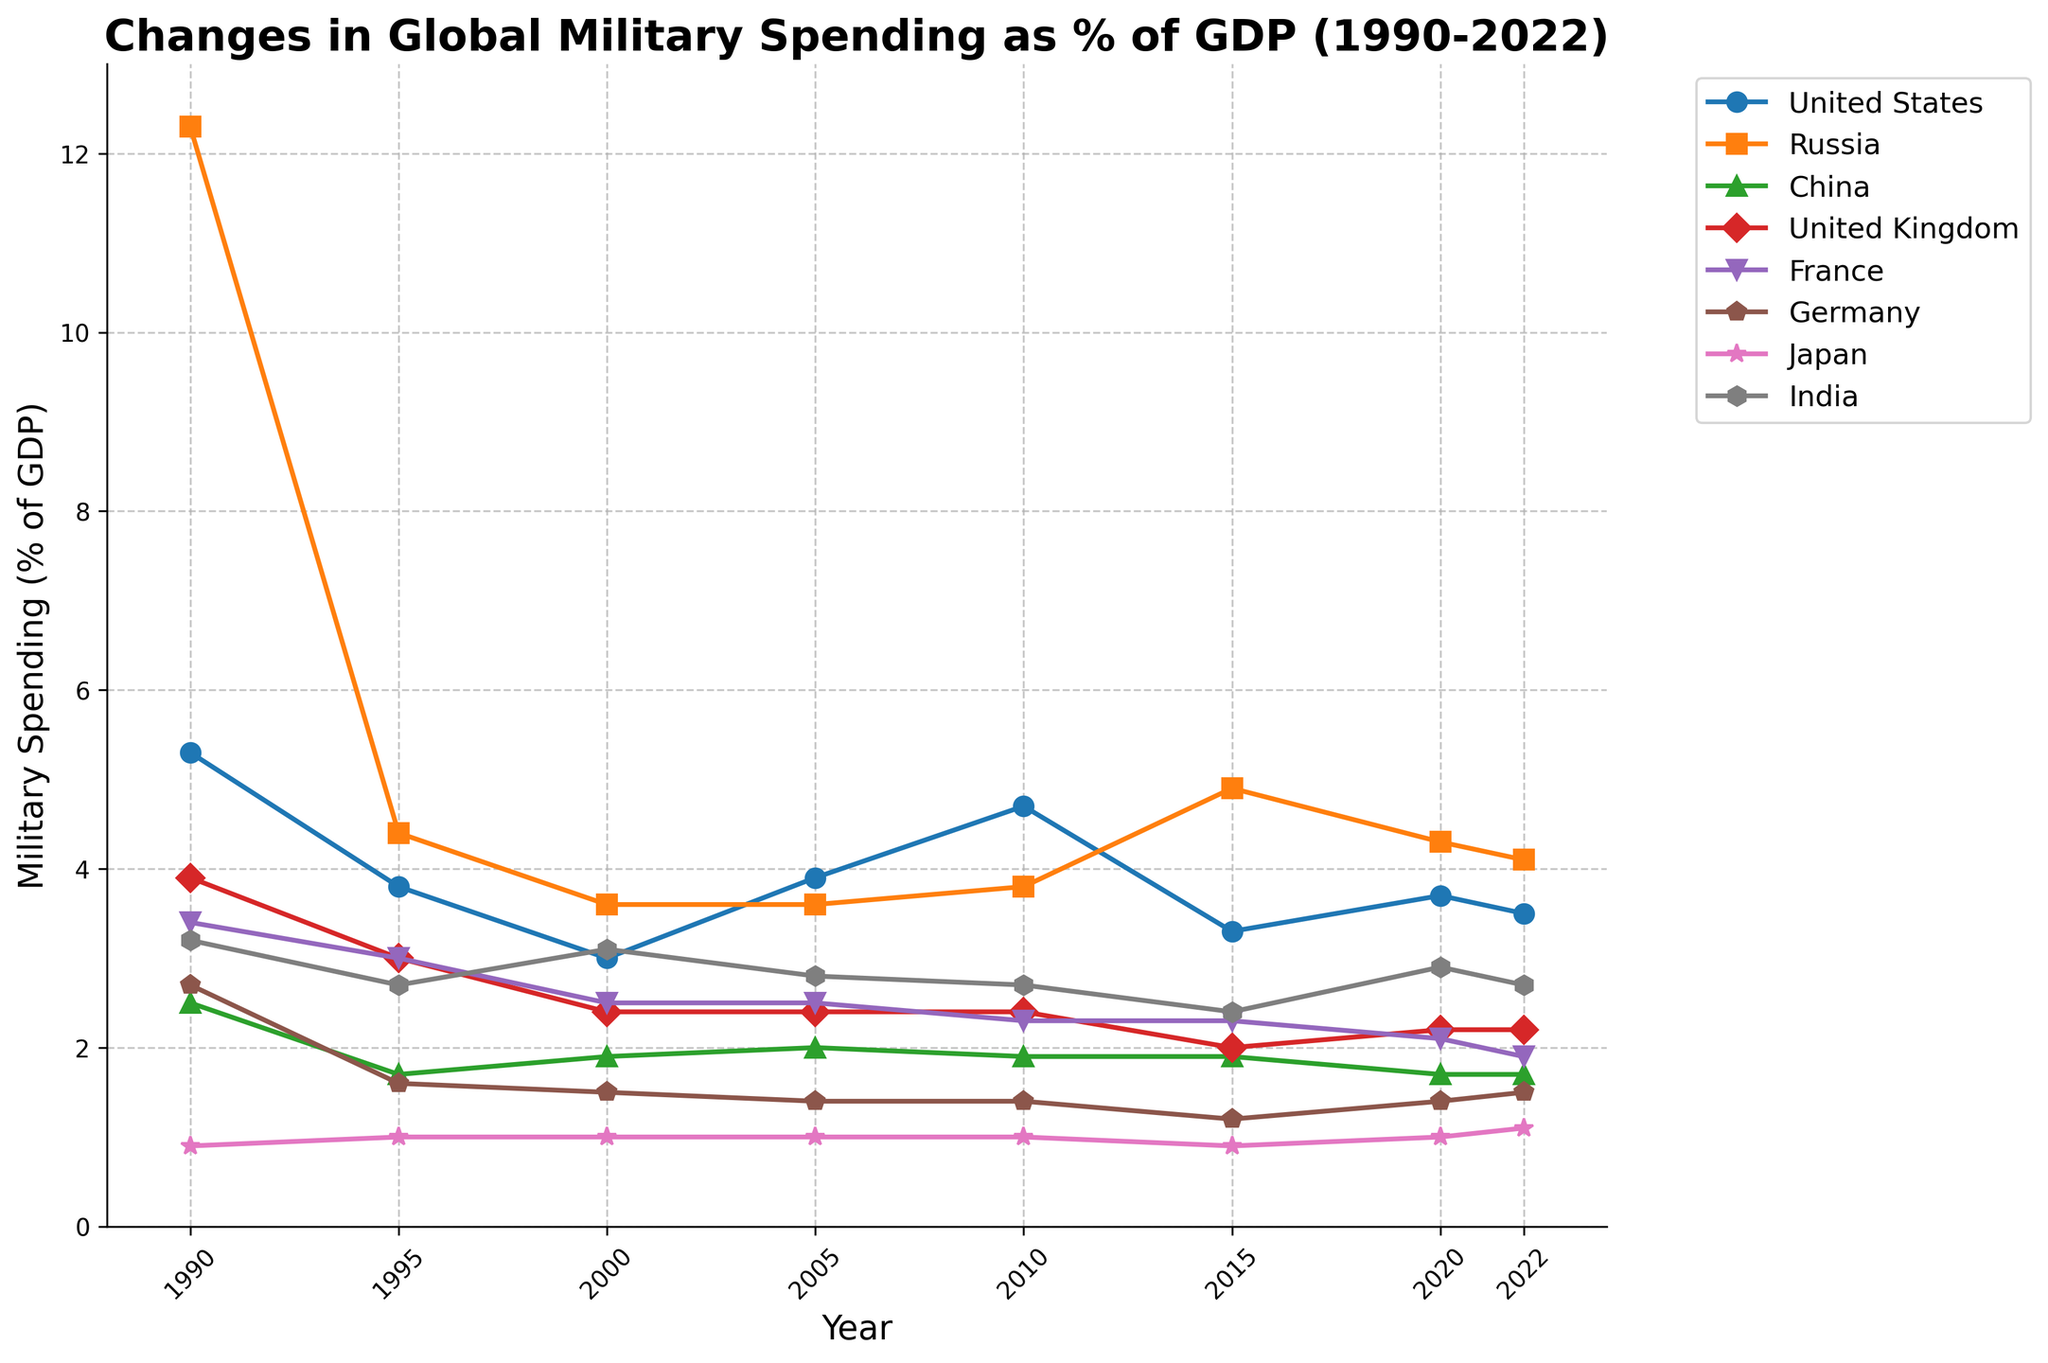What was the overall trend in military spending as a percentage of GDP for the United States from 1990 to 2022? The trend is obtained by inspecting the data points for the United States from 1990 to 2022 on the chart. Initially, it starts at 5.3% in 1990, decreases to a low of 3.0% by 2000, increases again to 4.7% by 2010, and then fluctuates slightly to 3.5% by 2022.
Answer: Fluctuating with an overall decrease Which country had the highest military spending as a percentage of GDP in 1990? By observing the data points for 1990, we compare military spending percentages for each country and identify the highest one. Russia has the highest percentage of military spending at 12.3% in 1990.
Answer: Russia Has China's military spending as a percentage of GDP been increasing or decreasing from 1990 to 2022? Looking at the data points for China from 1990 to 2022, we can see that it started at 2.5% and slightly decreased to 1.7% by 2022, showing a gradual decreasing trend.
Answer: Decreasing Between 2000 and 2022, which year had the largest increase in military spending as a percentage of GDP for Russia? By comparing Russia's military spending percentages year over year from 2000 to 2022, we see the largest increase occurs between 2010 (3.8%) and 2015 (4.9%), an increase of 1.1%.
Answer: 2015 What is the average military spending as a percentage of GDP for Germany from 1990 to 2022? To find the average, sum Germany's military spending percentages from 1990 (2.7%), 1995 (1.6%), 2000 (1.5%), 2005 (1.4%), 2010 (1.4%), 2015 (1.2%), 2020 (1.4%), 2022 (1.5%) and divide by the number of years (8). The calculation is (2.7 + 1.6 + 1.5 + 1.4 + 1.4 + 1.2 + 1.4 + 1.5) / 8 = 1.58.
Answer: 1.58 Which countries had a decrease in military spending as a percentage of GDP between 2010 and 2022? Evaluating the military spending percentage for each country in 2010 and comparing it with 2022, the countries that show a decrease are: United States (4.7% to 3.5%), China (1.9% to 1.7%), France (2.3% to 1.9%), and India (2.7% to 2.7%).
Answer: United States, China, France, India In which year did Japan have its lowest military spending as a percentage of GDP, and what was it? By looking at Japan's data points, the lowest spending percentage is in 2015 at 0.9%.
Answer: 2015, 0.9% Compare the trends in military spending as a percentage of GDP between the United Kingdom and France from 1990 to 2022. Observing the data trends for both countries: The United Kingdom starts at 3.9% and declines to 2.2% by 2022. France starts at 3.4% and declines to 1.9% by 2022. Both countries show a downward trend, but the United Kingdom has a steeper decline.
Answer: Both decreased, with the UK having a steeper decline Which country showed a stable trend in military spending percentage around 1.0% from 1990 to 2022? By inspecting the data points, Japan maintained a relatively stable trend around 1.0% of GDP from 1990 to 2022.
Answer: Japan 